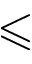<formula> <loc_0><loc_0><loc_500><loc_500>\leqslant</formula> 